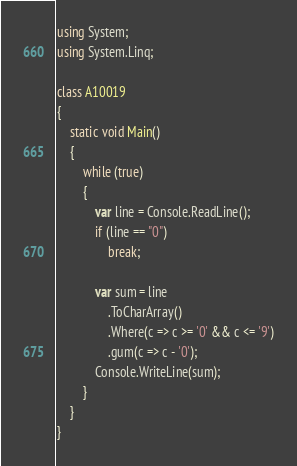Convert code to text. <code><loc_0><loc_0><loc_500><loc_500><_C#_>using System;
using System.Linq; 

class A10019
{
	static void Main()
	{
		while (true)
		{
			var line = Console.ReadLine();
			if (line == "0")
				break;

			var sum = line
				.ToCharArray()
				.Where(c => c >= '0' && c <= '9')
				.gum(c => c - '0');
			Console.WriteLine(sum);
		}
	}
}</code> 